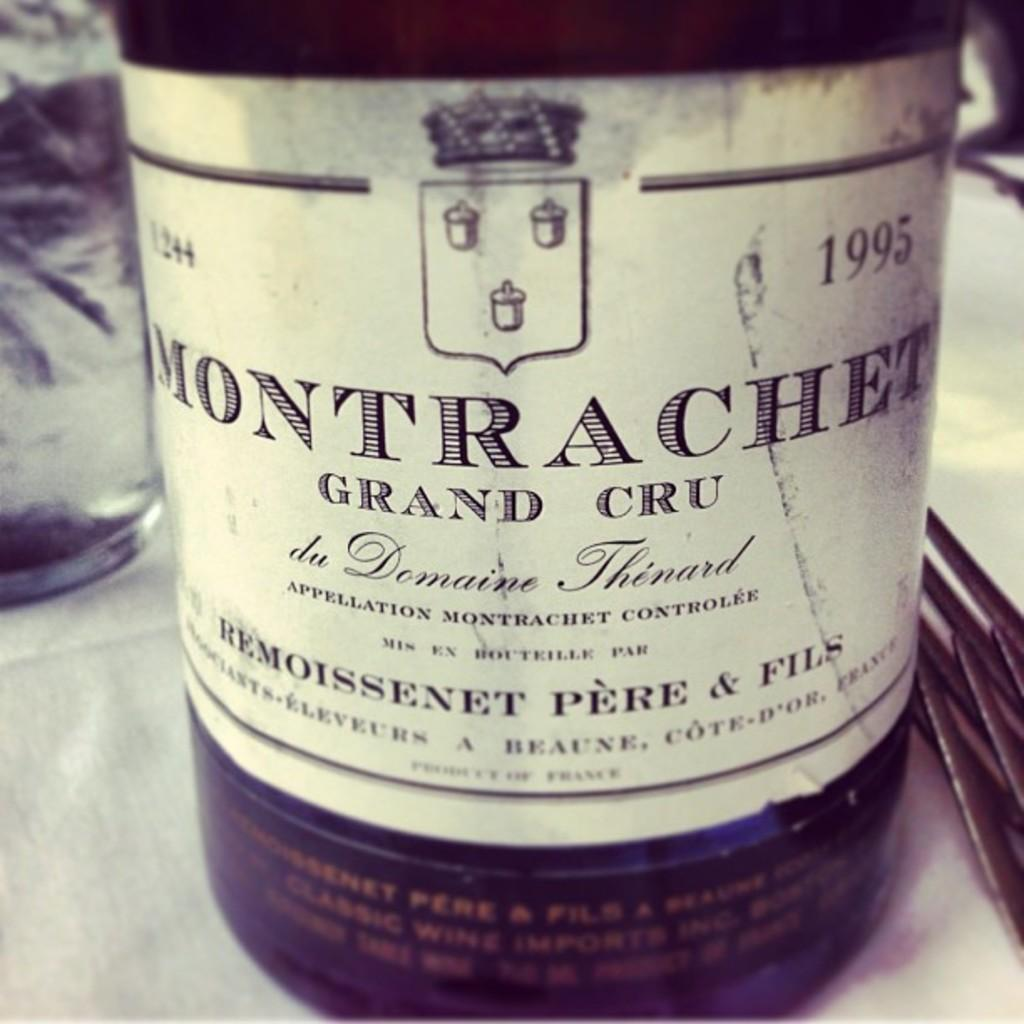What object can be seen in the image that is made of glass? There is a glass bottle in the image. What is on the glass bottle? The glass bottle has a label on it. What type of oatmeal is being prepared in the glass bottle? There is no oatmeal or preparation activity present in the image; it only features a glass bottle with a label on it. 